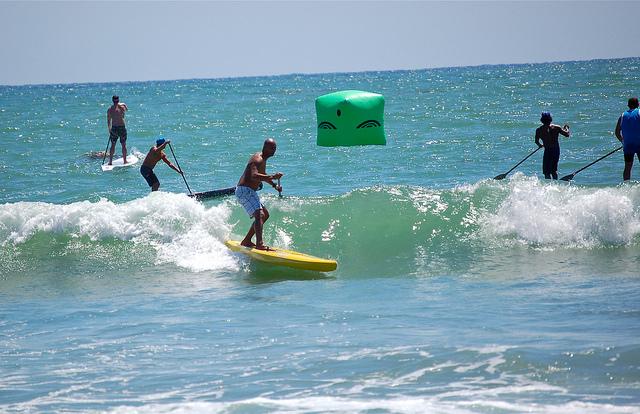What's the green object in the background?
Give a very brief answer. Kite. What is the man who is not surfing doing?
Keep it brief. Paddle boarding. Is the water cold?
Quick response, please. No. How many people are on the water?
Quick response, please. 5. What is the weather like in this image?
Concise answer only. Sunny. Is the man on the yellow board surfing?
Give a very brief answer. Yes. Are there any women in the picture?
Be succinct. No. How many sailboats are shown?
Give a very brief answer. 0. Are the men wearing bodysuits?
Quick response, please. No. 